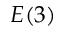Convert formula to latex. <formula><loc_0><loc_0><loc_500><loc_500>E ( 3 )</formula> 